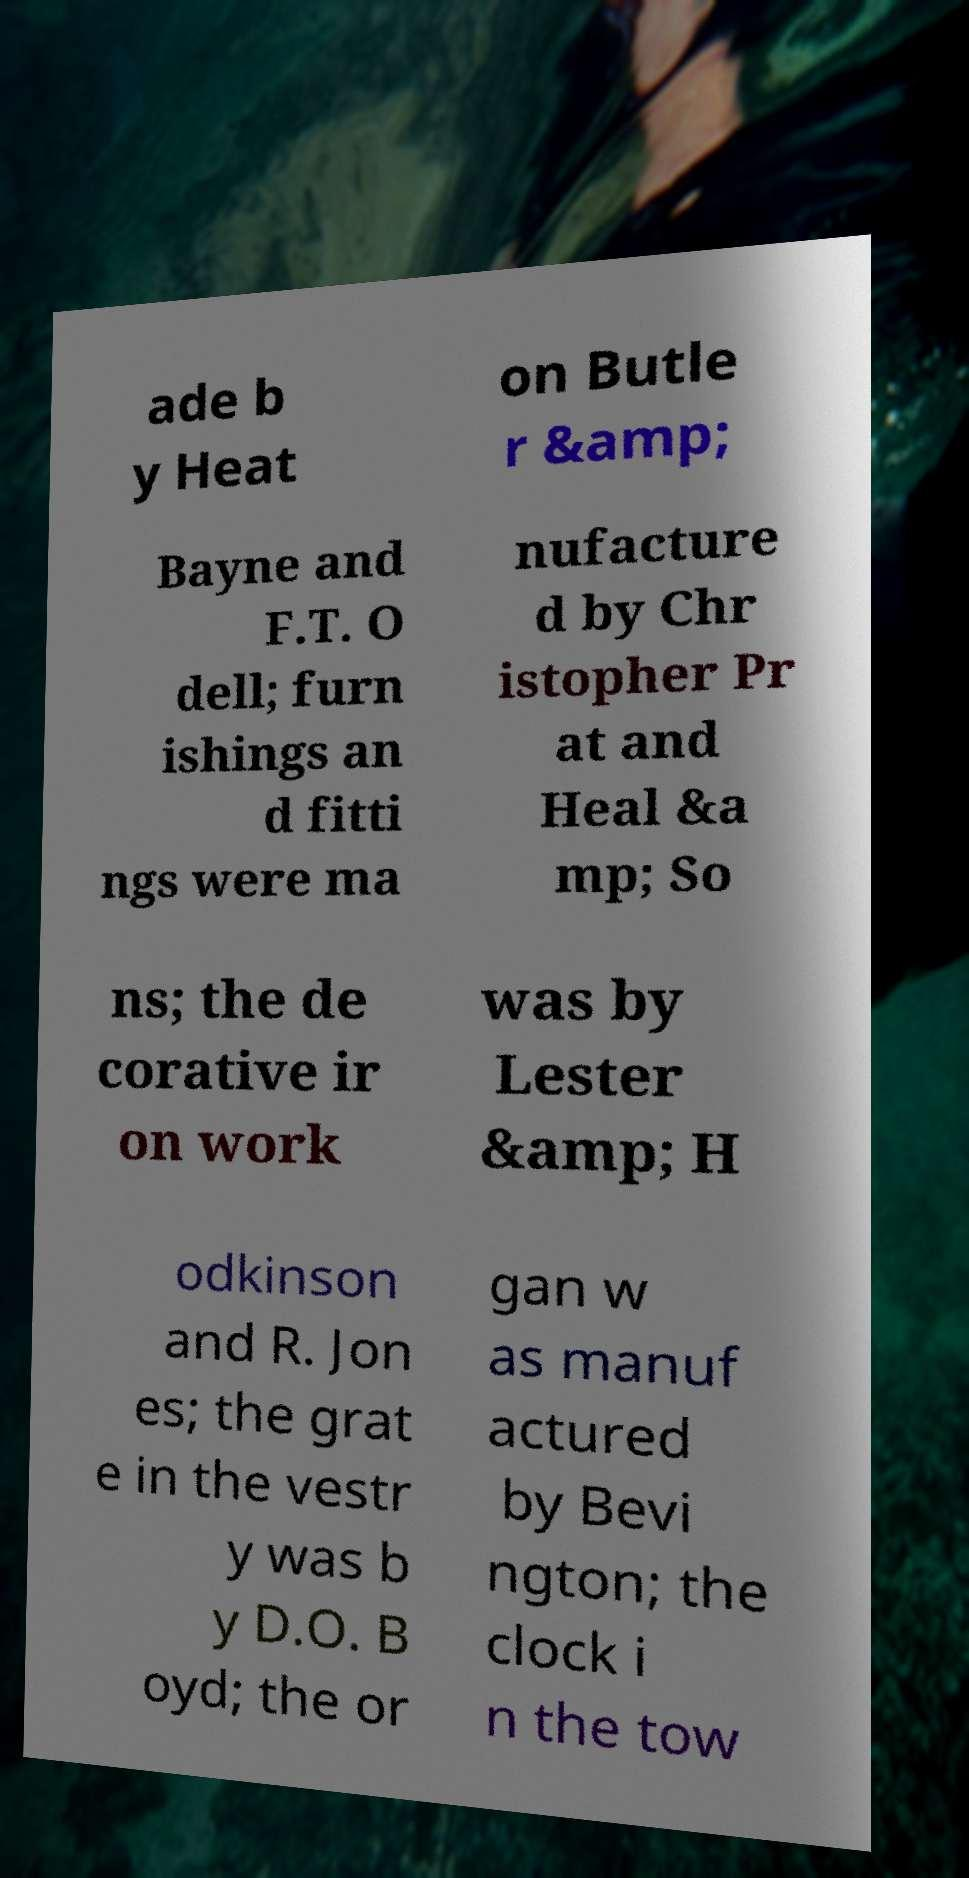There's text embedded in this image that I need extracted. Can you transcribe it verbatim? ade b y Heat on Butle r &amp; Bayne and F.T. O dell; furn ishings an d fitti ngs were ma nufacture d by Chr istopher Pr at and Heal &a mp; So ns; the de corative ir on work was by Lester &amp; H odkinson and R. Jon es; the grat e in the vestr y was b y D.O. B oyd; the or gan w as manuf actured by Bevi ngton; the clock i n the tow 